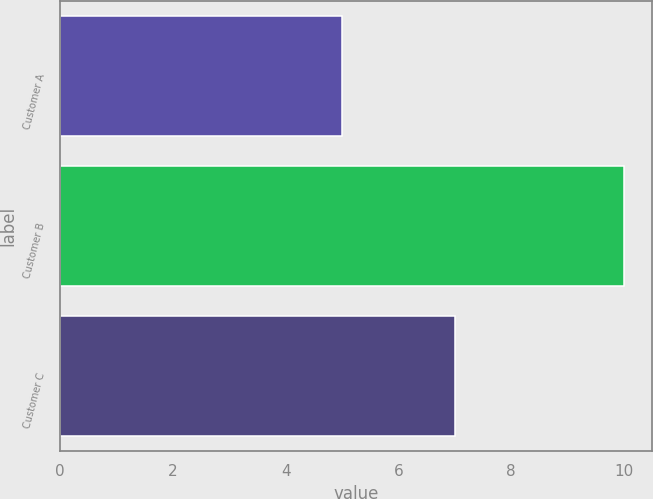Convert chart to OTSL. <chart><loc_0><loc_0><loc_500><loc_500><bar_chart><fcel>Customer A<fcel>Customer B<fcel>Customer C<nl><fcel>5<fcel>10<fcel>7<nl></chart> 